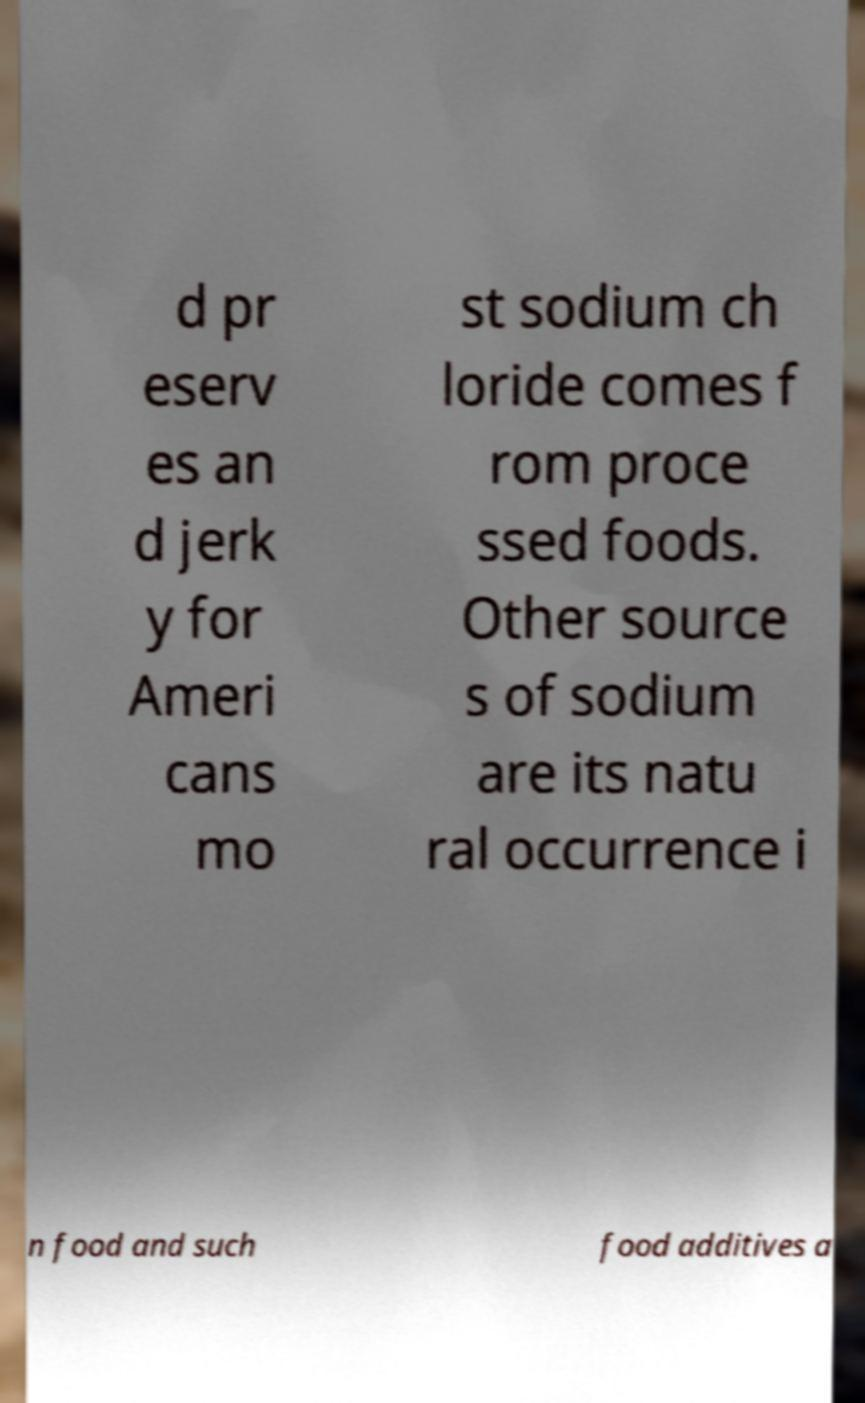Please identify and transcribe the text found in this image. d pr eserv es an d jerk y for Ameri cans mo st sodium ch loride comes f rom proce ssed foods. Other source s of sodium are its natu ral occurrence i n food and such food additives a 